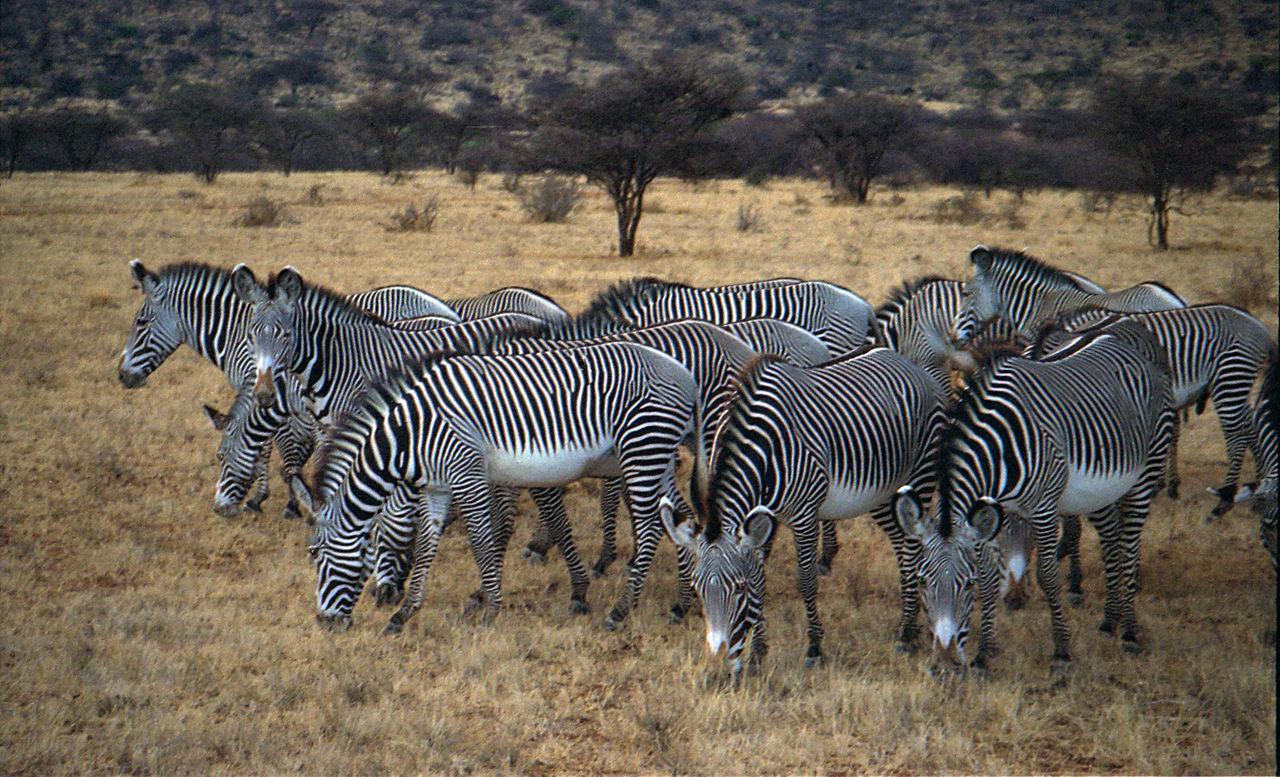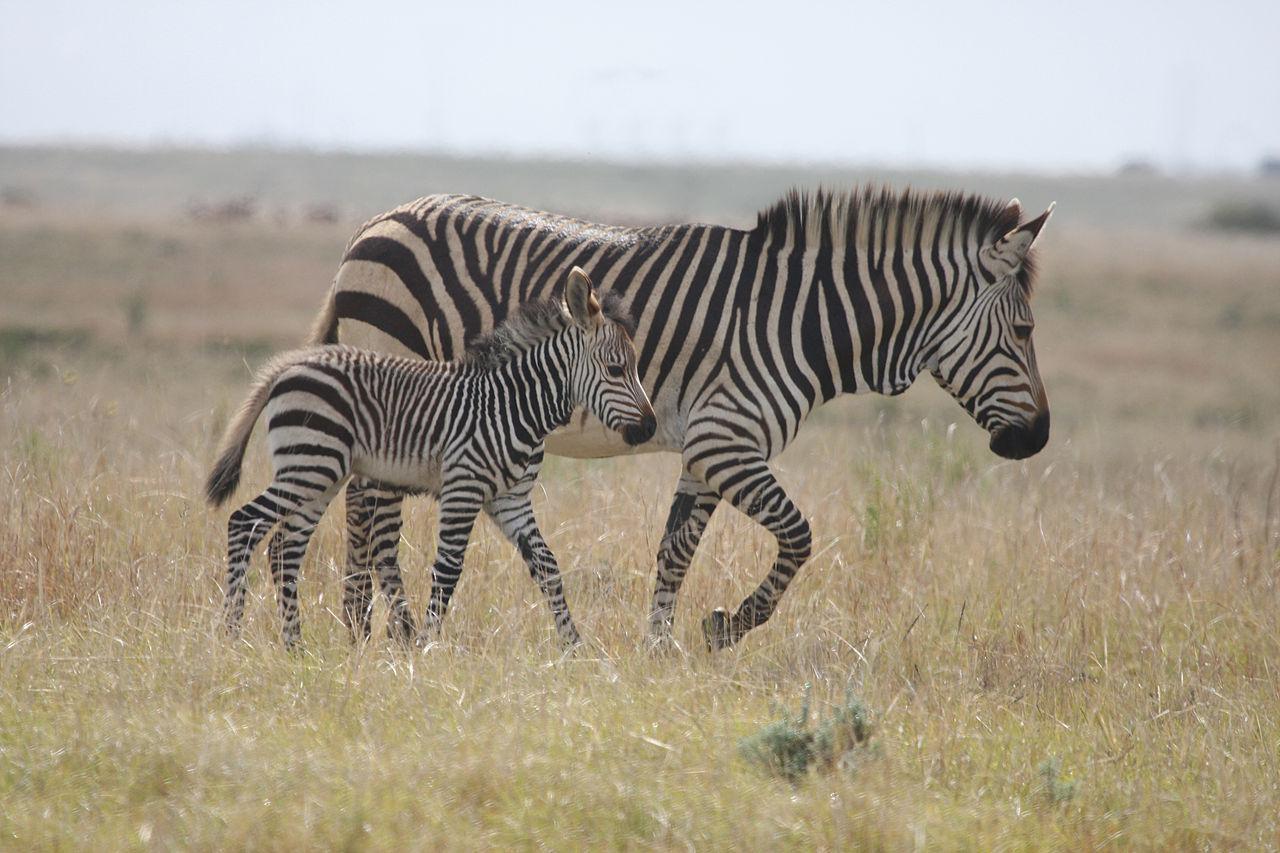The first image is the image on the left, the second image is the image on the right. For the images shown, is this caption "there are zebras standing in a row drinking water" true? Answer yes or no. No. The first image is the image on the left, the second image is the image on the right. Considering the images on both sides, is "One image shows leftward-facing zebras lined up with bent heads drinking from water they are standing in." valid? Answer yes or no. No. 